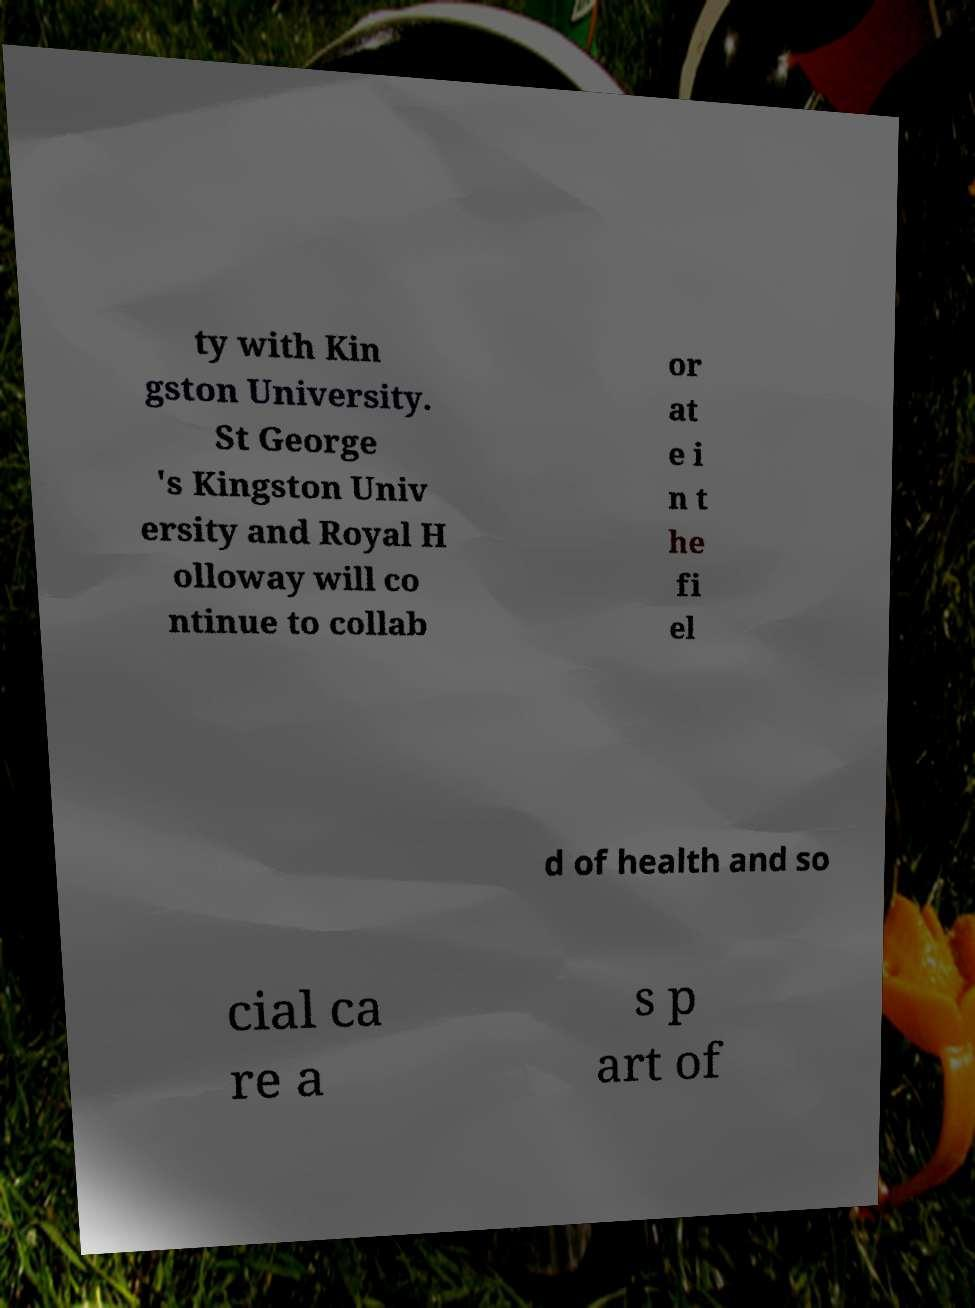Could you extract and type out the text from this image? ty with Kin gston University. St George 's Kingston Univ ersity and Royal H olloway will co ntinue to collab or at e i n t he fi el d of health and so cial ca re a s p art of 